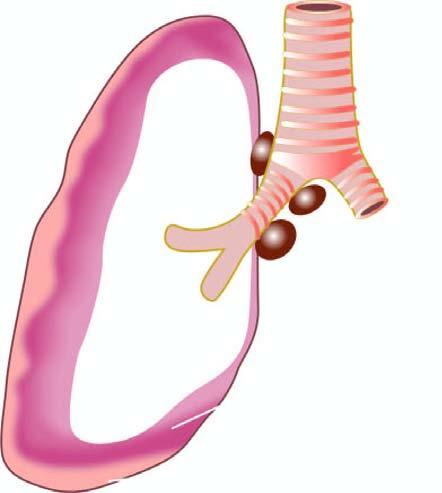s the tumour seen to form a thick, white, fleshy coat over the parietal and visceral surfaces?
Answer the question using a single word or phrase. Yes 